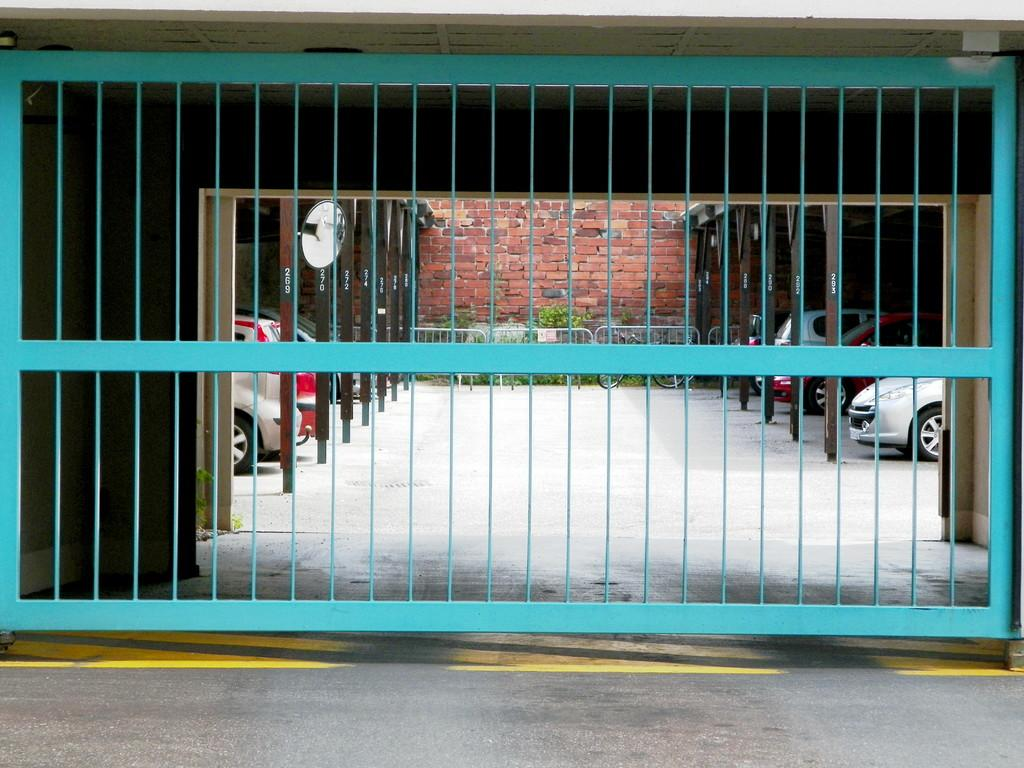What color is the railing in the image? The railing in the image is blue. What can be seen in the background of the image? There are vehicles visible in the background of the image, and they are under a shed. What type of vehicle is present in the image? The vehicles are not specified, but they are under a shed. What else is present in the image besides the railing and vehicles? There is a bicycle in the image. What is the color of the brick wall in the background of the image? The brick wall in the background of the image is brown. How many bulbs are attached to the bicycle in the image? There are no bulbs attached to the bicycle in the image. What type of wing is present on the railing in the image? There are no wings present on the railing in the image. 